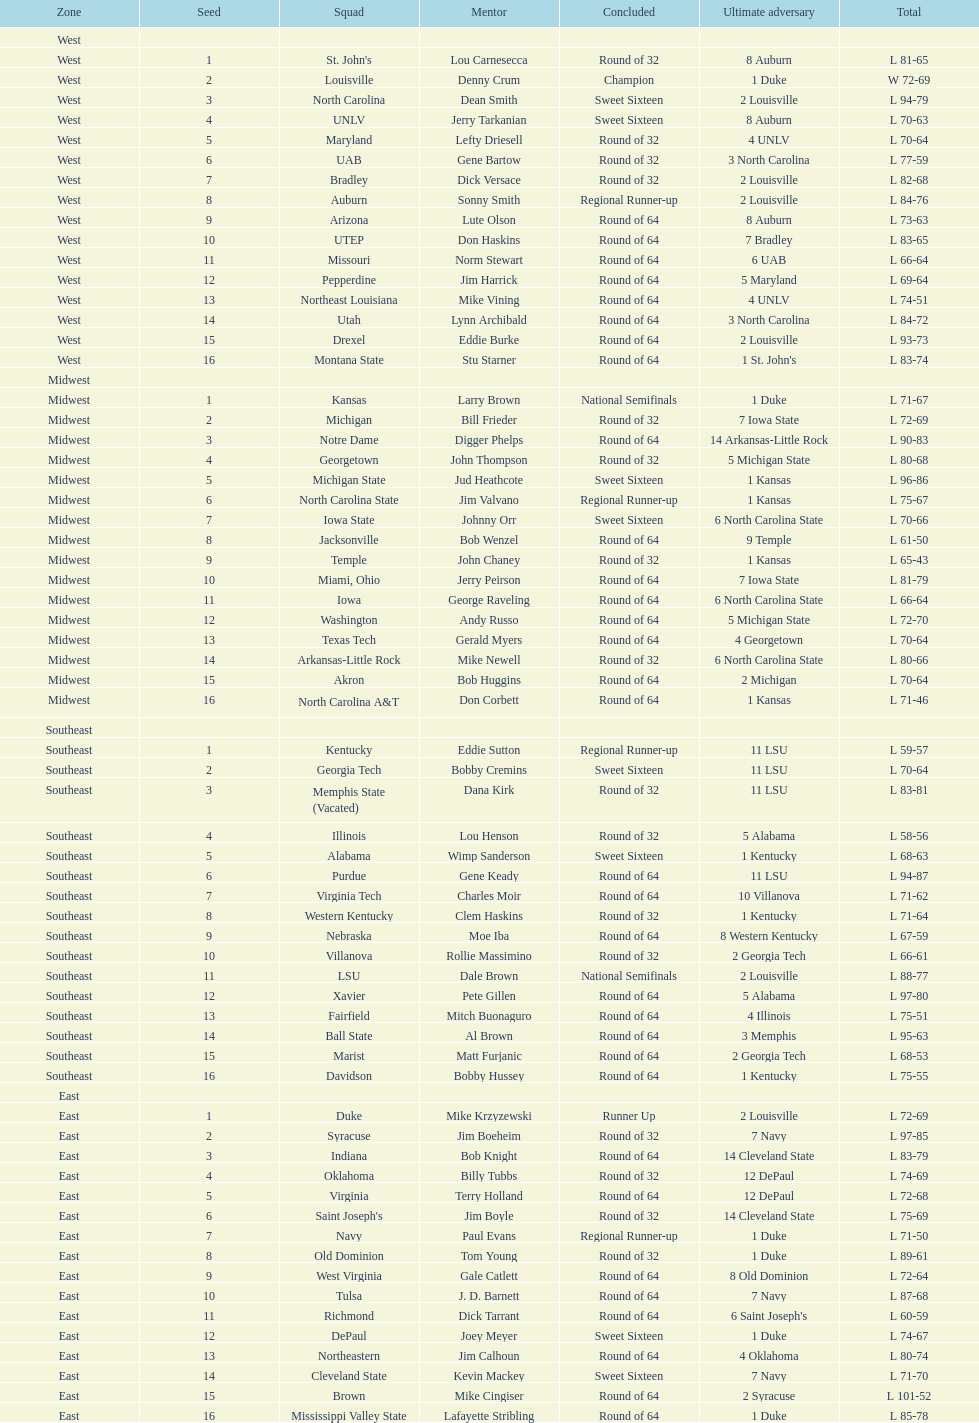How many number of teams played altogether? 64. 